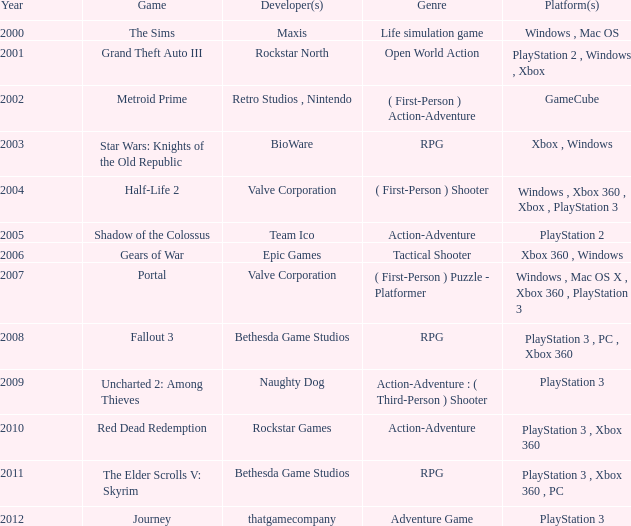Where can you find rockstar games as the developer of the platform? PlayStation 3 , Xbox 360. 